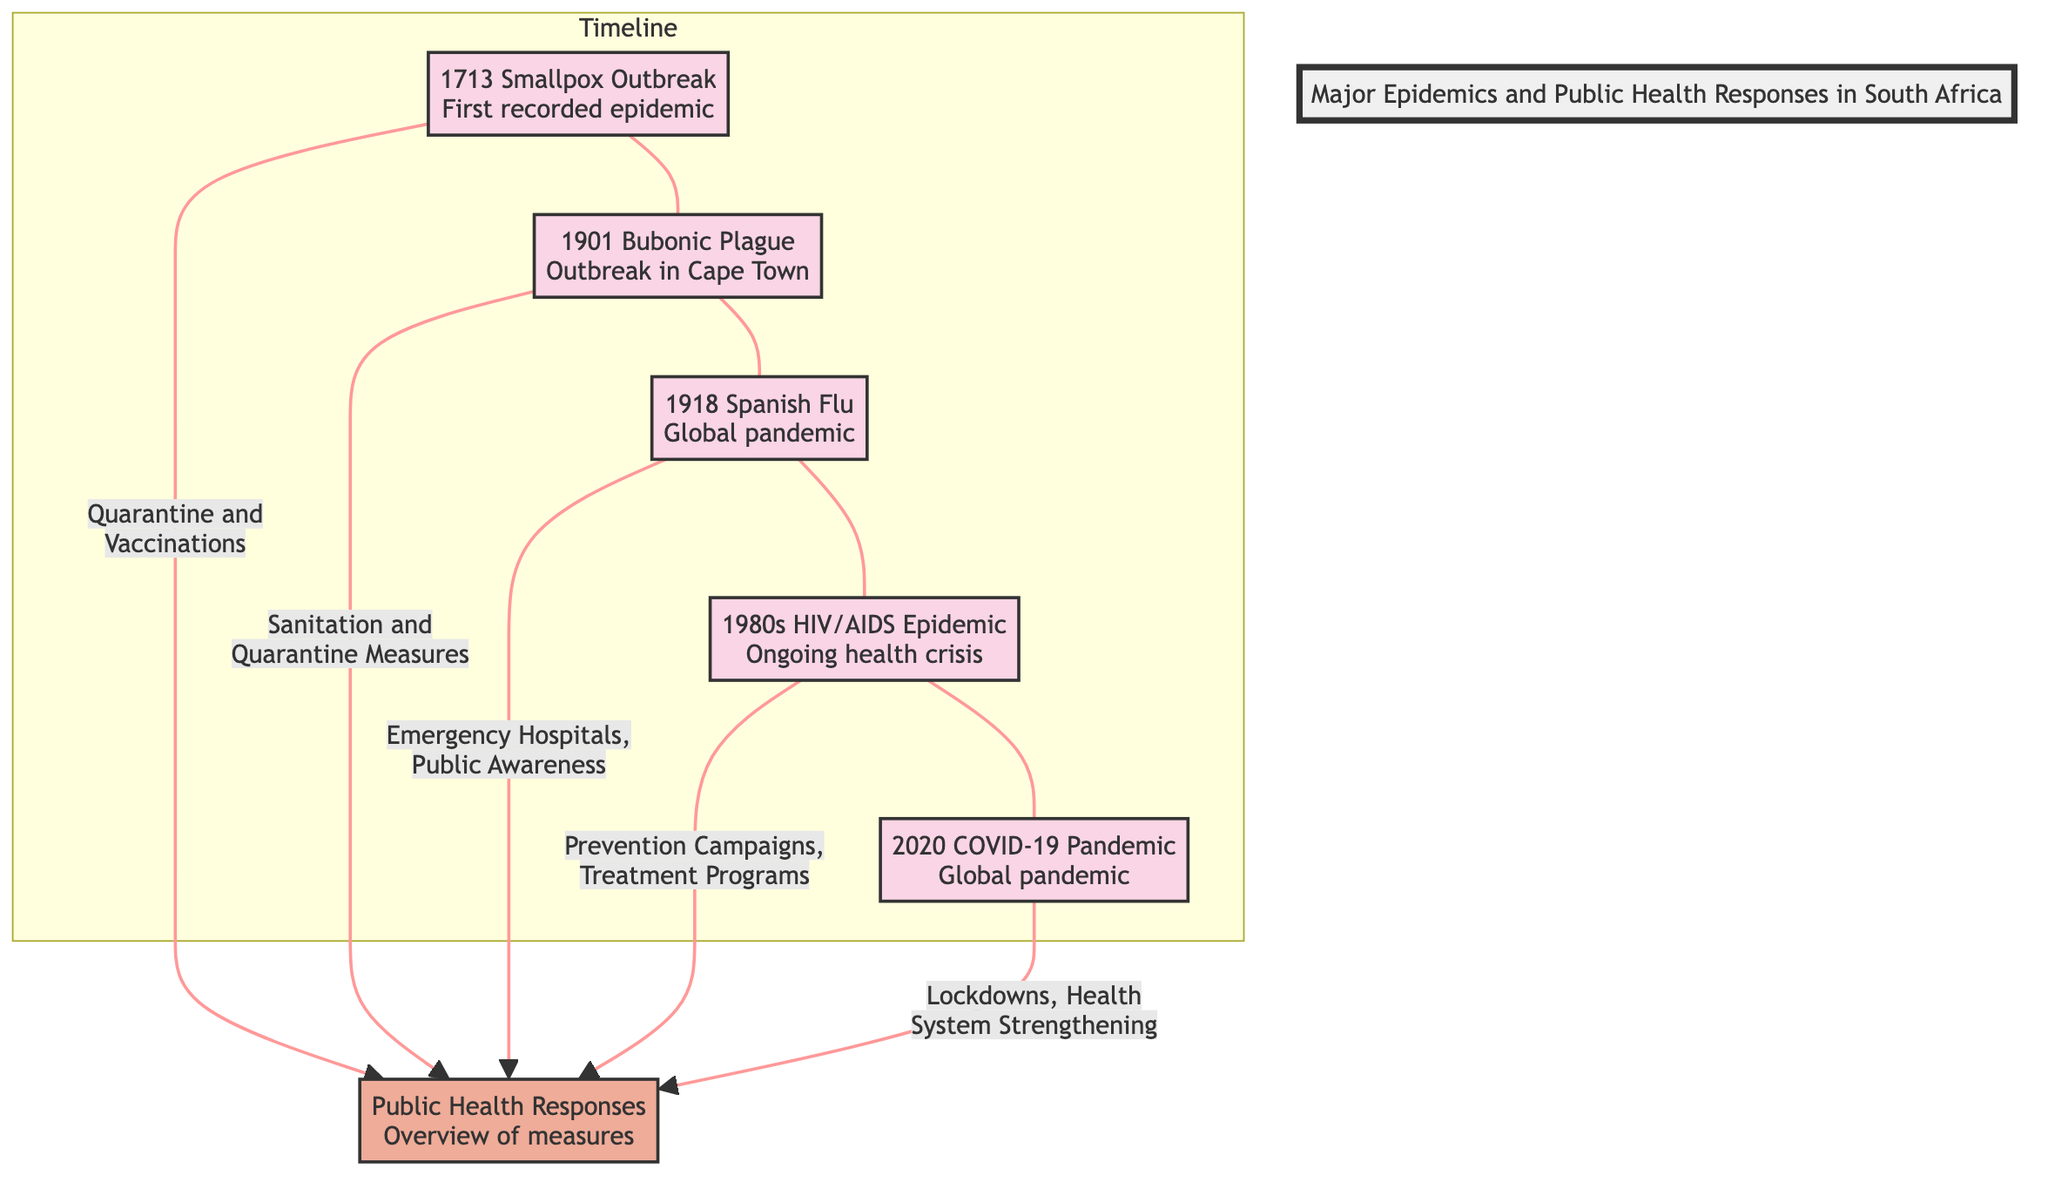What is the first recorded epidemic in South Africa? The diagram indicates that the first recorded epidemic in South Africa is the 1713 Smallpox Outbreak. This can be found at the beginning of the timeline linking to subsequent epidemics.
Answer: 1713 Smallpox Outbreak How many major epidemics are illustrated in the diagram? The diagram shows a total of five major epidemics: Smallpox, Bubonic Plague, Spanish Flu, HIV/AIDS, and COVID-19. By counting the main epidemic nodes in the flowchart, we find this total.
Answer: 5 What public health response was implemented during the Bubonic Plague outbreak? The Bubonic Plague outbreak in 1901 was addressed through sanitation and quarantine measures, as indicated by the connection from the Bubonic Plague node to the Public Health Responses node.
Answer: Sanitation and Quarantine Measures Which epidemic is linked to emergency hospitals and public awareness as a public health response? The connection from the Spanish Flu node shows that emergency hospitals and public awareness were key responses to the 1918 Spanish Flu, making it evident that these measures were specifically linked to this epidemic.
Answer: Spanish Flu What has been the ongoing health crisis recognized since the 1980s? Referring to the diagram, the HIV/AIDS epidemic, marked as ongoing since the 1980s, is identified as the major health crisis during that period, as represented in the timeline and descriptive label.
Answer: HIV/AIDS Epidemic What connection exists between the COVID-19 pandemic and public health responses? The diagram shows that the COVID-19 pandemic is linked to public health responses that include lockdowns and health system strengthening. By analyzing the arrows leading from this node, we see the implemented strategies clearly listed.
Answer: Lockdowns, Health System Strengthening Which epidemic was observed in Cape Town in 1901? By examining the timeline in the diagram, it is clear that the Bubonic Plague outbreak occurred in Cape Town in 1901, as directly stated in the node associated with that epidemic.
Answer: Bubonic Plague What type of public health response was associated with the Smallpox outbreak? The diagram indicates that the public health responses to the Smallpox outbreak included quarantine and vaccinations, as shown by the arrow leading from the Smallpox Outbreak to the Public Health Responses node, which details the corresponding measures.
Answer: Quarantine and Vaccinations 